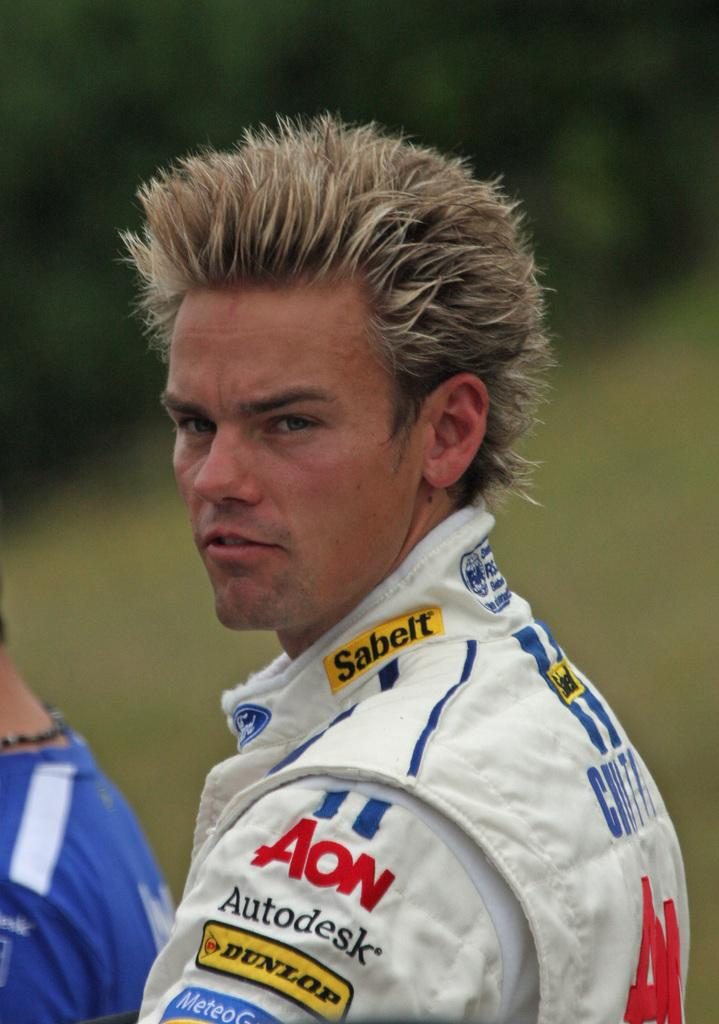<image>
Provide a brief description of the given image. The driver pictured has the word Sabelt on the neck of his clothing. 